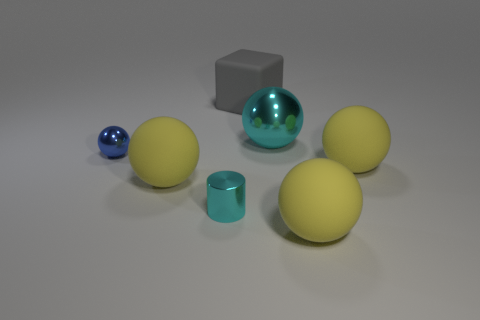Are there any cyan metallic objects? yes 